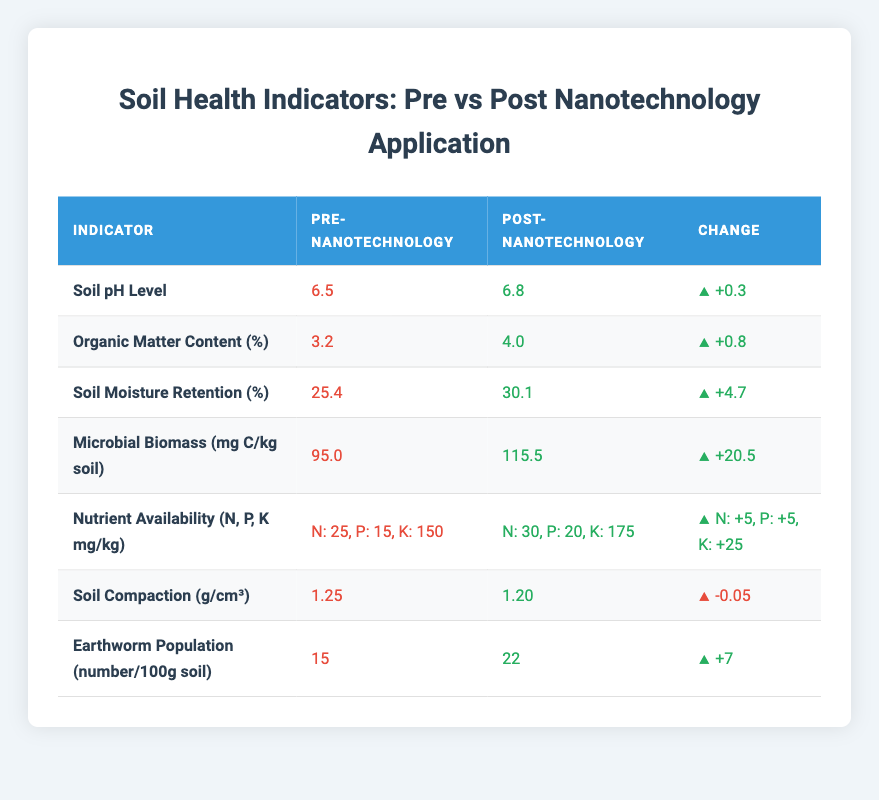What was the Soil pH Level before nanotechnology application? The Soil pH Level before nanotechnology application is listed in the table under the "Pre-Nanotechnology" column for that indicator. It shows a value of 6.5.
Answer: 6.5 What is the percentage increase in Organic Matter Content after the application of nanotechnology? To find the percentage increase, subtract the pre-nanotechnology value of 3.2 from the post-nanotechnology value of 4.0, which gives a difference of 0.8. Then, divide the increase (0.8) by the original value (3.2) and multiply by 100, resulting in (0.8 / 3.2) * 100 = 25%.
Answer: 25% Is the Soil Compaction greater before or after the application of nanotechnology? By comparing the values for Soil Compaction in both columns, it shows the pre-nanotechnology value is 1.25 and the post-nanotechnology value is 1.20. Because 1.25 is greater than 1.20, it indicates that Soil Compaction is greater before than after the application.
Answer: Yes What is the change in Microbial Biomass from pre- to post-nanotechnology application? The change for Microbial Biomass can be found by subtracting the pre-nanotechnology value of 95.0 from the post-nanotechnology value of 115.5, which equals a change of 20.5.
Answer: +20.5 How much did Nutrient Availability for potassium (K) increase after the application of nanotechnology? The table shows that the pre-nanotechnology potassium value is 150 mg/kg and the post-nanotechnology value is 175 mg/kg. To find the increase, subtract 150 from 175, resulting in an increase of 25 mg/kg.
Answer: +25 Did the Earthworm Population increase or decrease following the application of nanotechnology? By comparing the Earthworm Population before and after application, we see the pre-nanotechnology value is 15 and the post is 22. Since 22 is greater than 15, the Earthworm Population increased after the application.
Answer: Yes What was the average increase in Soil Moisture Retention and Earthworm Population together? The increase in Soil Moisture Retention is 4.7 and the increase in Earthworm Population is 7. To find the average increase, sum these increases (4.7 + 7 = 11.7) and divide by 2, resulting in an average increase of 5.85.
Answer: 5.85 Which soil health indicator showed the largest change following nanotechnology application? By analyzing the changes, Soil Moisture Retention shows an increase of 4.7%, Microbial Biomass shows an increase of 20.5, and Earthworm Population increases by 7. Among these, the highest change is in Microbial Biomass with an increase of 20.5.
Answer: Microbial Biomass What was the total N, P, and K nutrient availability before nanotechnology application? The nutrient availability before application shows N is 25 mg/kg, P is 15 mg/kg, and K is 150 mg/kg. To find the total, we add these values together: 25 + 15 + 150 = 190 mg/kg.
Answer: 190 